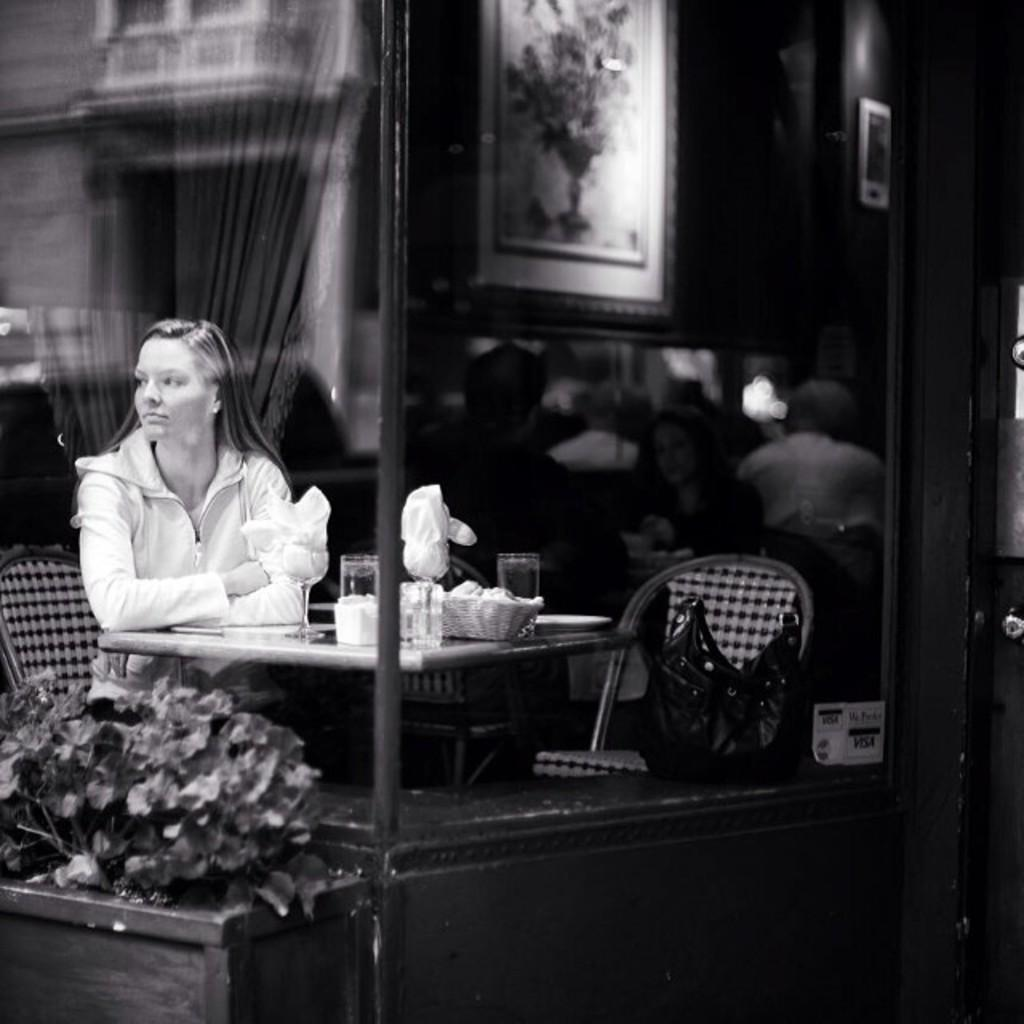Who is the main subject in the image? There is a woman in the image. What is the woman doing in the image? The woman is sitting on a chair. Where is the woman located in the image? The woman is on the left side of the image. What other objects can be seen in the image? There is a table in the image, as well as a glass and tissues on the table. What type of dress is the woman wearing to help with her stomach pain in the image? There is no mention of a dress or stomach pain in the image. The woman is simply sitting on a chair, and there is a table with a glass and tissues on it. 